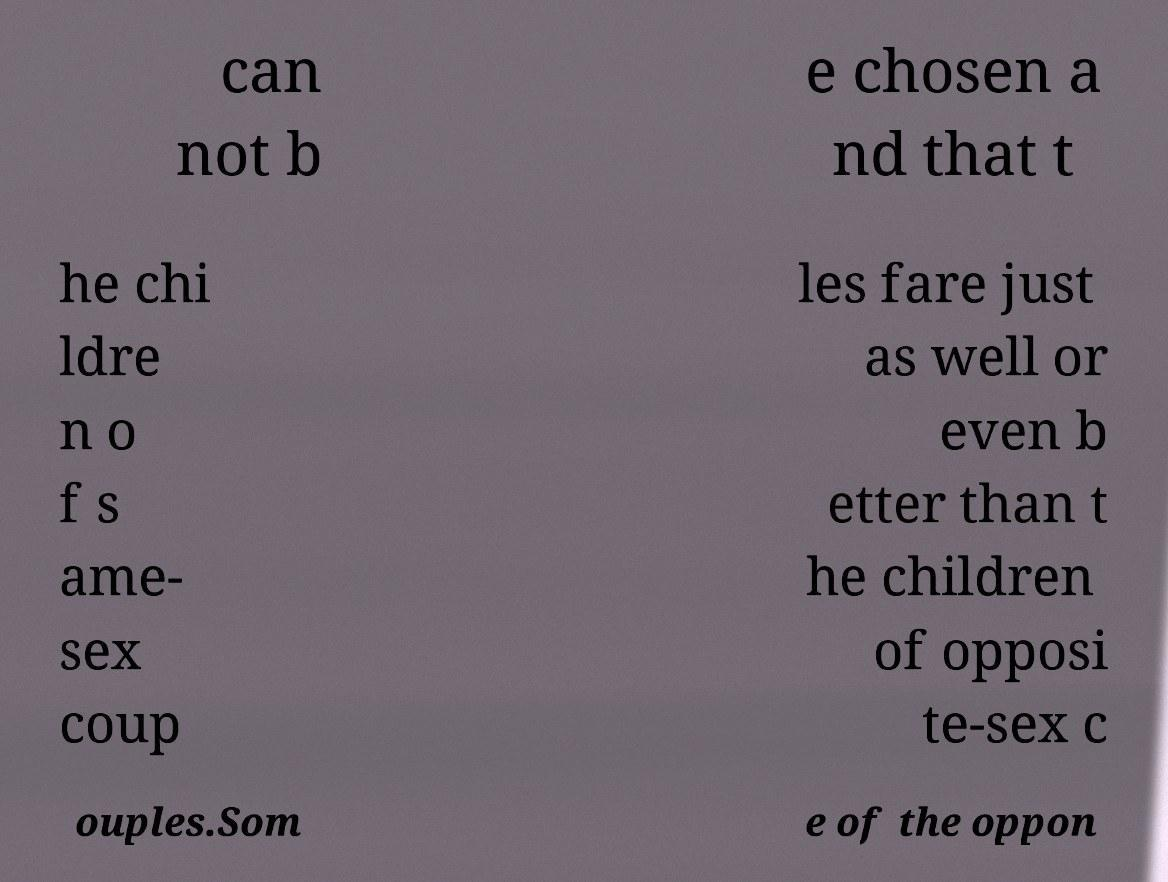Please read and relay the text visible in this image. What does it say? can not b e chosen a nd that t he chi ldre n o f s ame- sex coup les fare just as well or even b etter than t he children of opposi te-sex c ouples.Som e of the oppon 